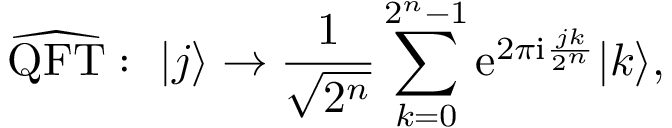Convert formula to latex. <formula><loc_0><loc_0><loc_500><loc_500>\widehat { Q F T } \colon | j \rangle \to \frac { 1 } { \sqrt { 2 ^ { n } } } \sum _ { k = 0 } ^ { 2 ^ { n } - 1 } e ^ { 2 \pi i \frac { j k } { 2 ^ { n } } } | k \rangle ,</formula> 